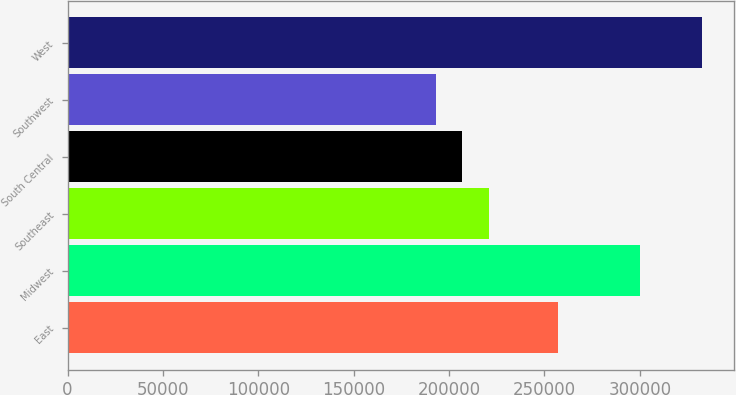<chart> <loc_0><loc_0><loc_500><loc_500><bar_chart><fcel>East<fcel>Midwest<fcel>Southeast<fcel>South Central<fcel>Southwest<fcel>West<nl><fcel>257200<fcel>299800<fcel>220920<fcel>206960<fcel>193000<fcel>332600<nl></chart> 